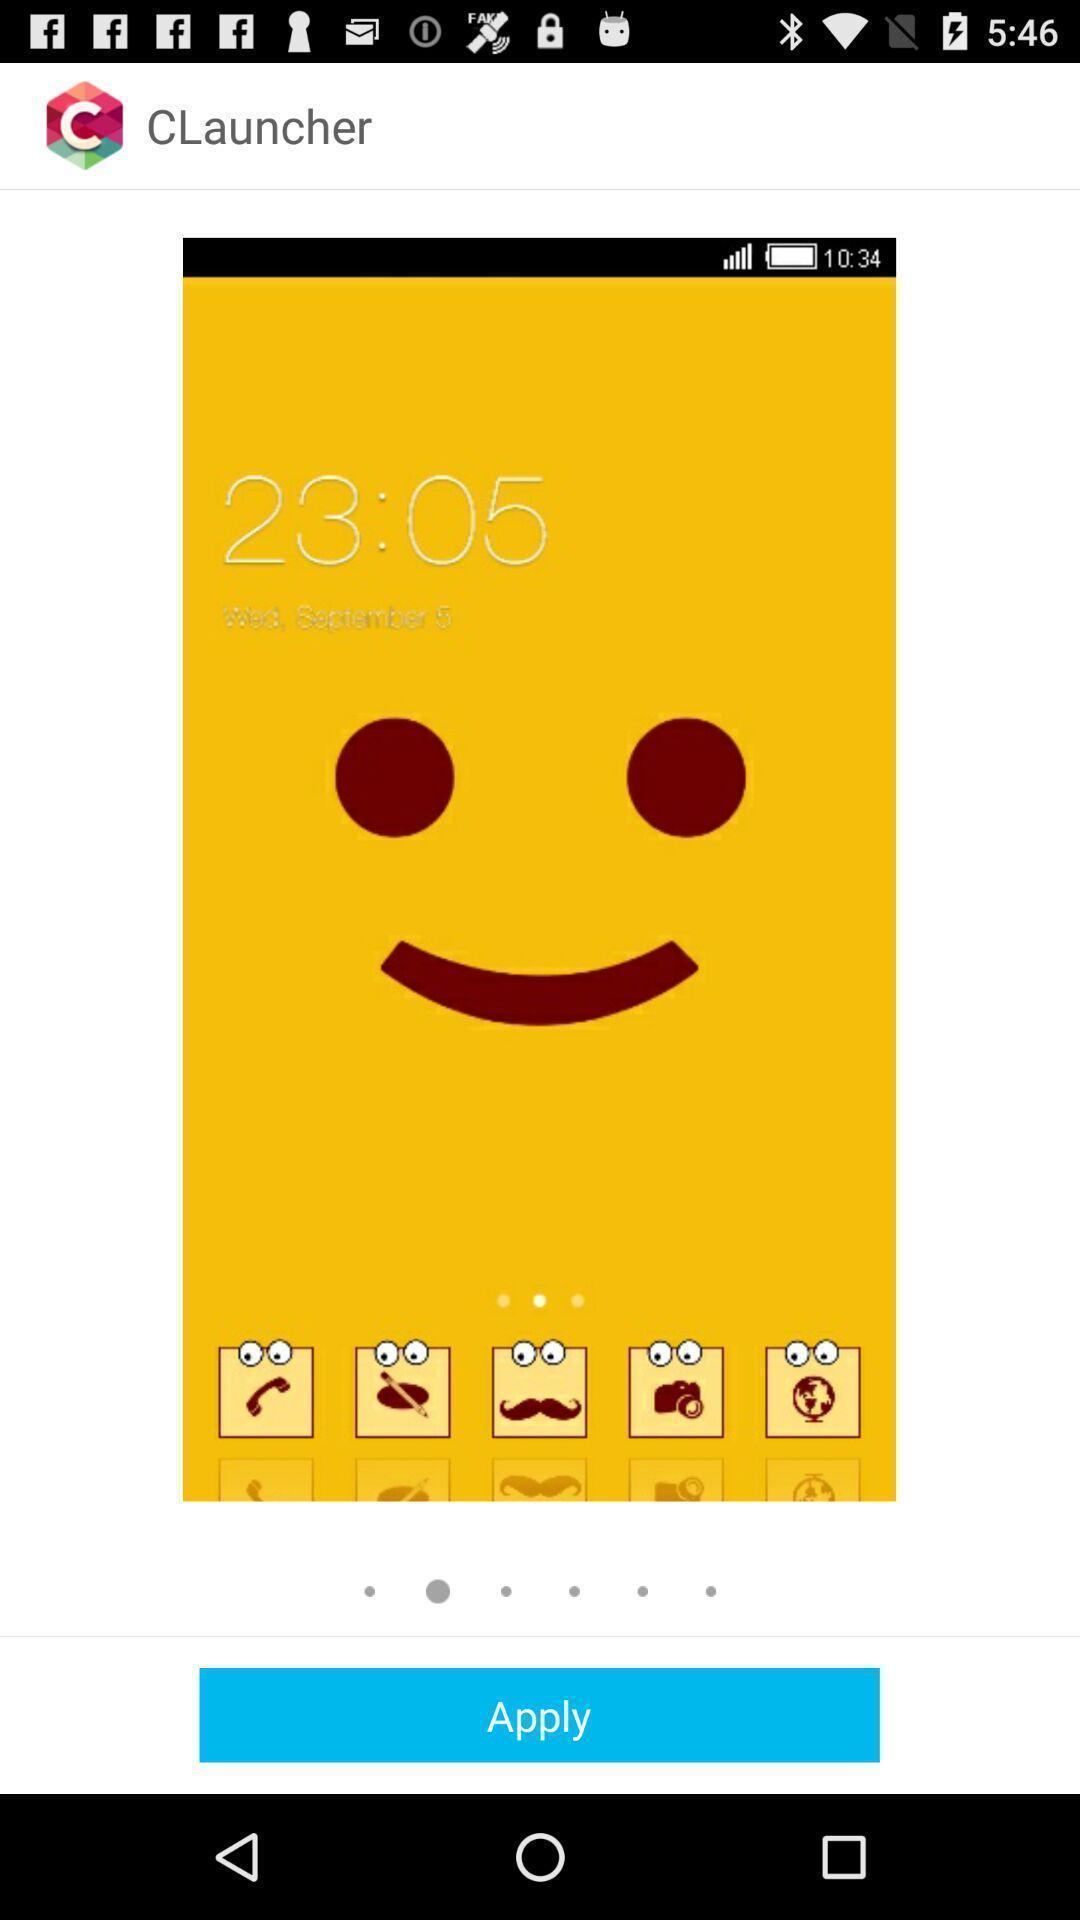Explain the elements present in this screenshot. Screen shows wallpapers on a device. 